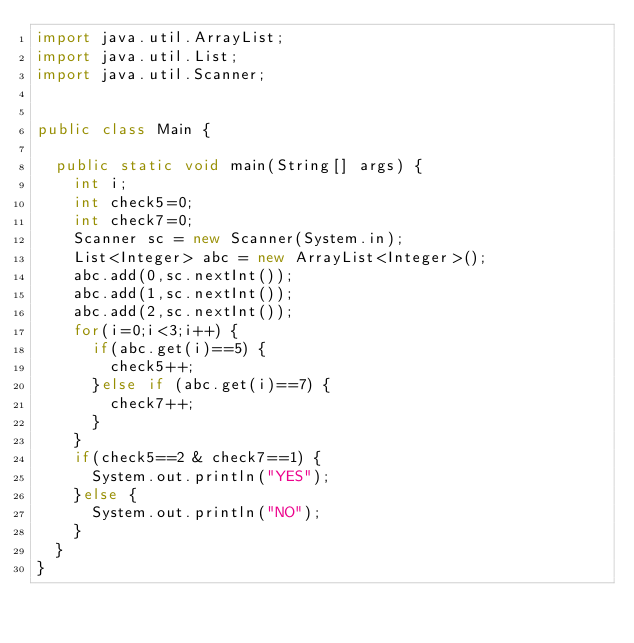<code> <loc_0><loc_0><loc_500><loc_500><_Java_>import java.util.ArrayList;
import java.util.List;
import java.util.Scanner;


public class Main {

	public static void main(String[] args) {
		int i;
		int check5=0;
		int check7=0;
		Scanner sc = new Scanner(System.in);
		List<Integer> abc = new ArrayList<Integer>();
		abc.add(0,sc.nextInt()); 
		abc.add(1,sc.nextInt()); 
		abc.add(2,sc.nextInt()); 
		for(i=0;i<3;i++) {
			if(abc.get(i)==5) {
				check5++;
			}else if (abc.get(i)==7) {
				check7++;
			}	
		}
		if(check5==2 & check7==1) {
			System.out.println("YES");
		}else {
			System.out.println("NO");
		}
	}
}</code> 